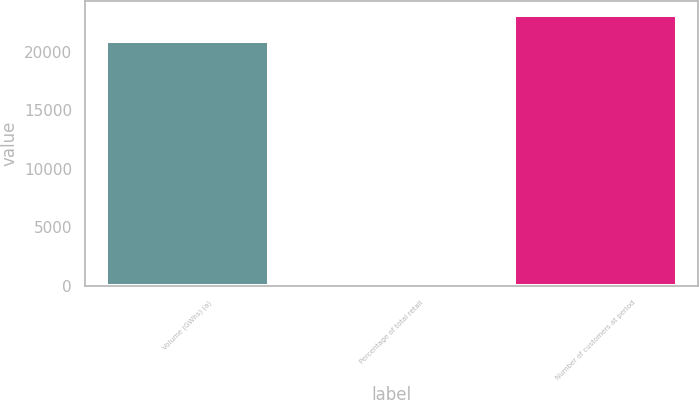Convert chart to OTSL. <chart><loc_0><loc_0><loc_500><loc_500><bar_chart><fcel>Volume (GWhs) (a)<fcel>Percentage of total retail<fcel>Number of customers at period<nl><fcel>20939<fcel>24<fcel>23152.7<nl></chart> 